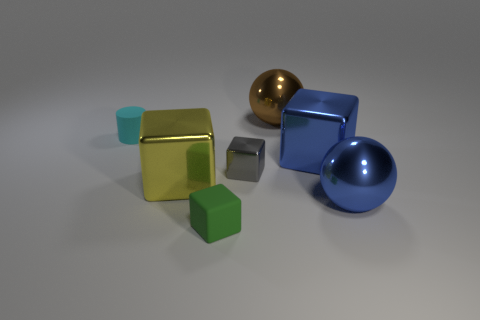There is a gray thing that is the same size as the cyan rubber thing; what material is it?
Make the answer very short. Metal. Are there the same number of large yellow metallic blocks that are on the right side of the yellow object and green matte spheres?
Your answer should be very brief. Yes. What number of other objects are the same color as the small shiny block?
Your answer should be very brief. 0. What is the color of the small object that is left of the gray metallic object and on the right side of the large yellow block?
Ensure brevity in your answer.  Green. What is the size of the rubber cube in front of the ball to the left of the large ball that is in front of the tiny metal cube?
Provide a succinct answer. Small. What number of things are either tiny things that are on the left side of the small green block or big blocks that are right of the yellow metal thing?
Make the answer very short. 2. The yellow thing has what shape?
Give a very brief answer. Cube. What number of other objects are the same material as the small cyan cylinder?
Ensure brevity in your answer.  1. What size is the green object that is the same shape as the large yellow metal thing?
Offer a very short reply. Small. What material is the large cube that is to the right of the thing that is behind the small matte thing behind the gray metallic object made of?
Keep it short and to the point. Metal. 